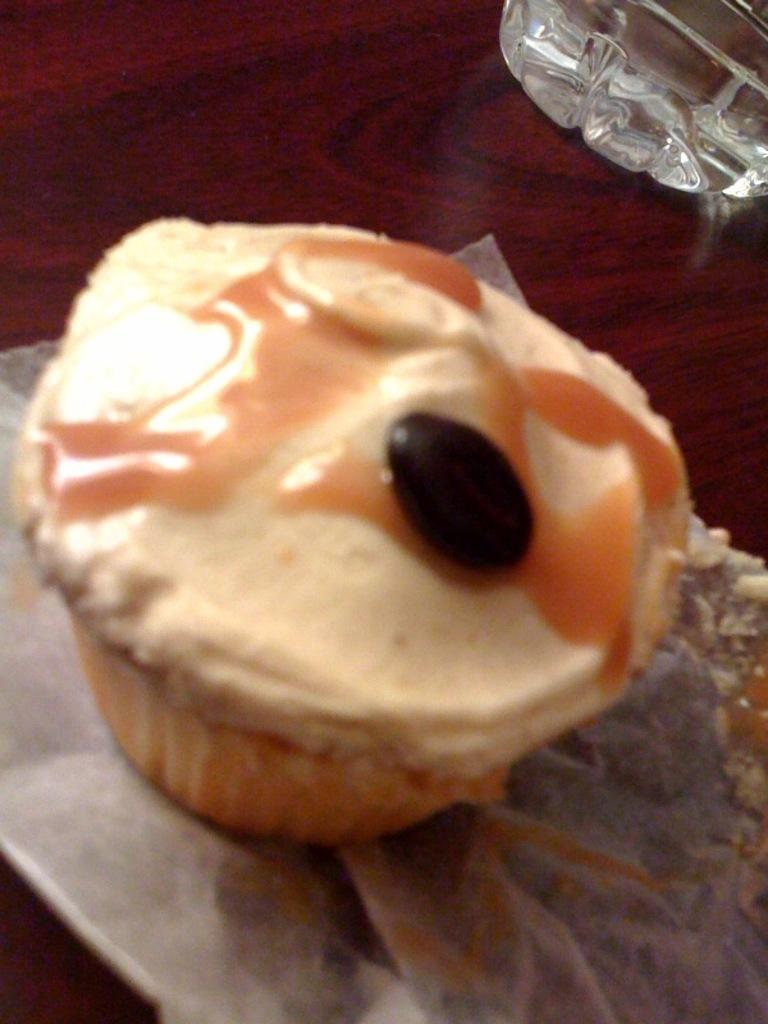What type of dessert is in the image? There is a cupcake in the image. What color is the cupcake? The cupcake is cream-colored. On what surface is the cupcake placed? The cupcake is placed on a maroon-colored table. What other object can be seen in the image? There is a glass on the right side of the image. Can you see a duck quacking in the image? No, there is no duck present in the image. What type of berry is used as a topping on the cupcake? There is no berry mentioned or visible on the cupcake in the image. 